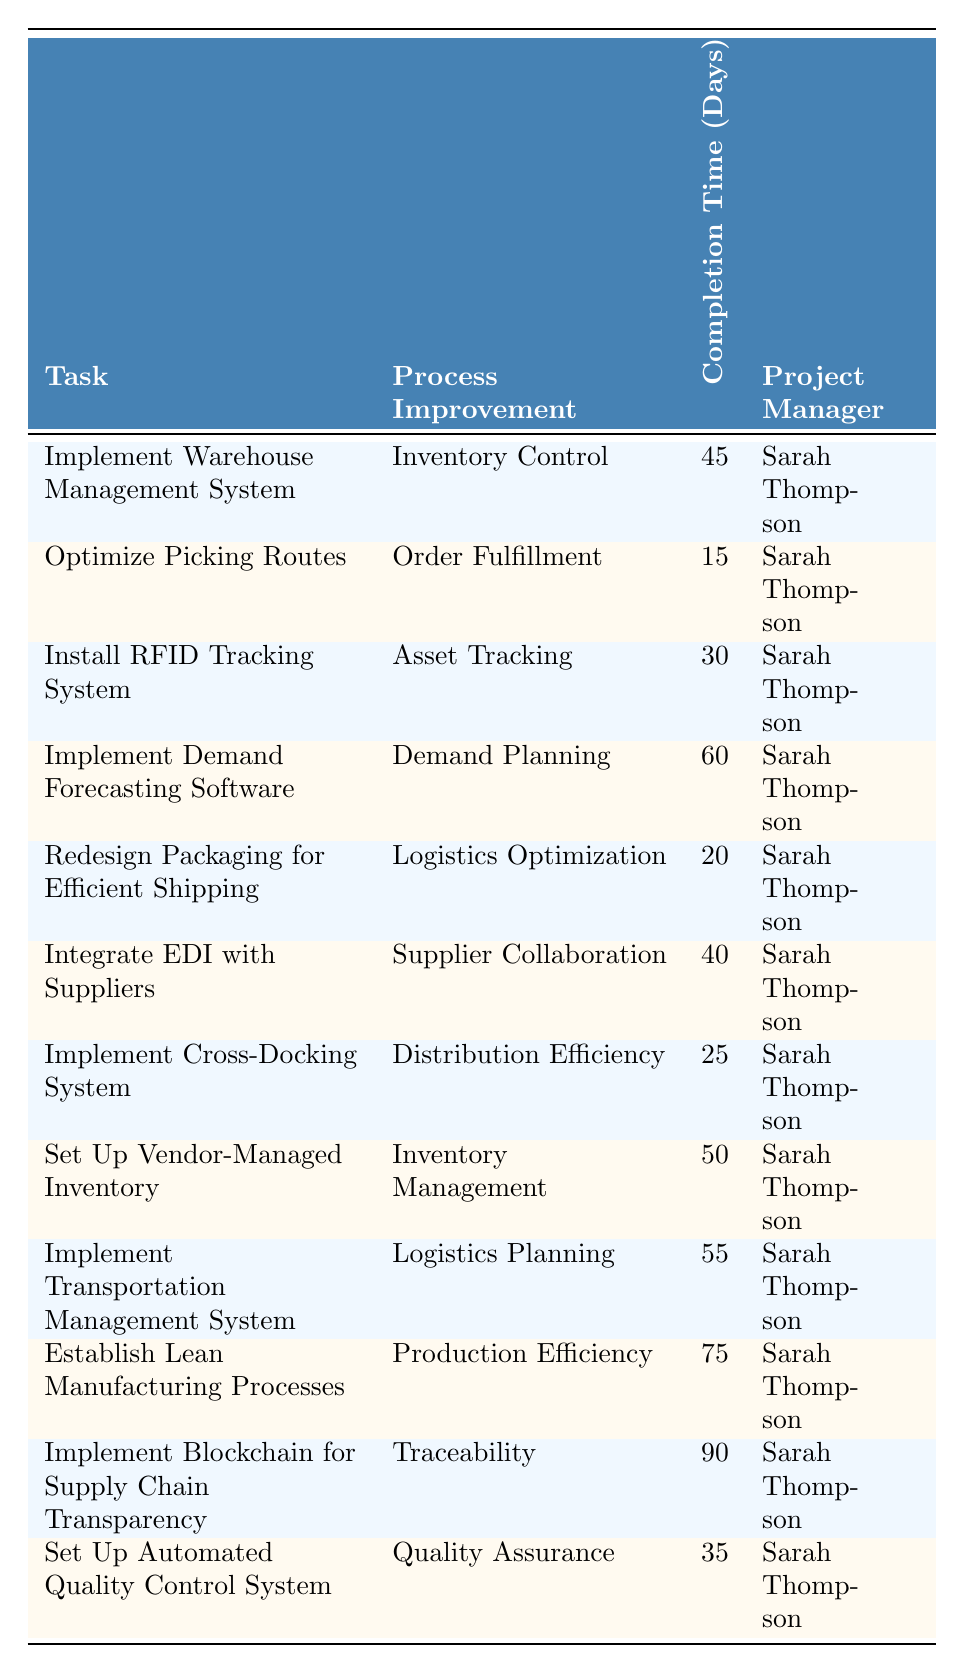What is the completion time for implementing the Transportation Management System? According to the table, the completion time listed for the task of implementing the Transportation Management System is 55 days.
Answer: 55 days Which task has the longest completion time? The table lists the tasks with their corresponding completion times. Scanning through the times, the task 'Implement Blockchain for Supply Chain Transparency' has the longest completion time of 90 days.
Answer: 90 days How many tasks have a completion time of less than 30 days? By reviewing the completion times, I find two tasks: 'Optimize Picking Routes' (15 days) and 'Redesign Packaging for Efficient Shipping' (20 days) that complete in less than 30 days. Thus, there are two tasks.
Answer: 2 What is the average completion time for all listed tasks? First, I add all the completion times together: 45 + 15 + 30 + 60 + 20 + 40 + 25 + 50 + 55 + 75 + 90 + 35 =  495. Then, I divide by the number of tasks (12): 495/12 = 41.25. Therefore, the average completion time is 41.25 days.
Answer: 41.25 days Is there a task involving logistics that takes more than 50 days to complete? Looking at the 'Logistics Planning' task (55 days), it confirms that it involves logistics and exceeds 50 days, making the answer yes.
Answer: Yes Which project manager is responsible for the task with the lowest completion time? 'Optimize Picking Routes' is the task with the lowest completion time of 15 days. According to the table, Sarah Thompson is the project manager for this task.
Answer: Sarah Thompson What is the difference in completion time between the 'Establish Lean Manufacturing Processes' and 'Optimize Picking Routes' tasks? The completion time for 'Establish Lean Manufacturing Processes' is 75 days and for 'Optimize Picking Routes' is 15 days. The difference is 75 - 15 = 60 days.
Answer: 60 days How many tasks have a completion time of exactly 50 days? Checking the table, I notice there is only one task, 'Set Up Vendor-Managed Inventory,' that has a completion time of exactly 50 days.
Answer: 1 Is the task 'Implement Demand Forecasting Software' related to Logistics Optimization? The task is classified under 'Demand Planning', which is unrelated to Logistics Optimization, so the answer is no.
Answer: No Which process improvement has the shortest completion time? Looking through the table, 'Order Fulfillment,' associated with 'Optimize Picking Routes,' has the shortest completion time of 15 days, confirming it as the shortest.
Answer: Order Fulfillment 